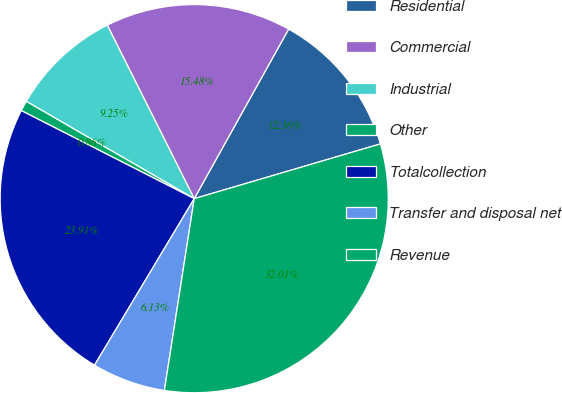<chart> <loc_0><loc_0><loc_500><loc_500><pie_chart><fcel>Residential<fcel>Commercial<fcel>Industrial<fcel>Other<fcel>Totalcollection<fcel>Transfer and disposal net<fcel>Revenue<nl><fcel>12.36%<fcel>15.48%<fcel>9.25%<fcel>0.86%<fcel>23.91%<fcel>6.13%<fcel>32.01%<nl></chart> 